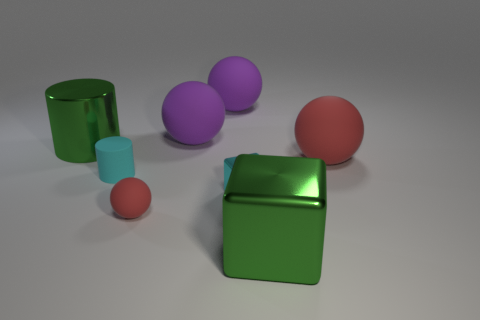What's the color scheme of the image? The color scheme consists of muted and pastel colors. There are objects in green, red, purple, and blue nicely contrasted against the neutral gray background. Do the objects seem to be in any specific arrangement? The objects appear to be arranged randomly with no discernible pattern, some are standing, and one of the green cylinders is lying on its side. Could the arrangement suggest anything about motion or stability? Yes, the green cylinder lying on its side suggests motion or the possibility of it having been rolled, while the other objects standing upright suggest stability. 